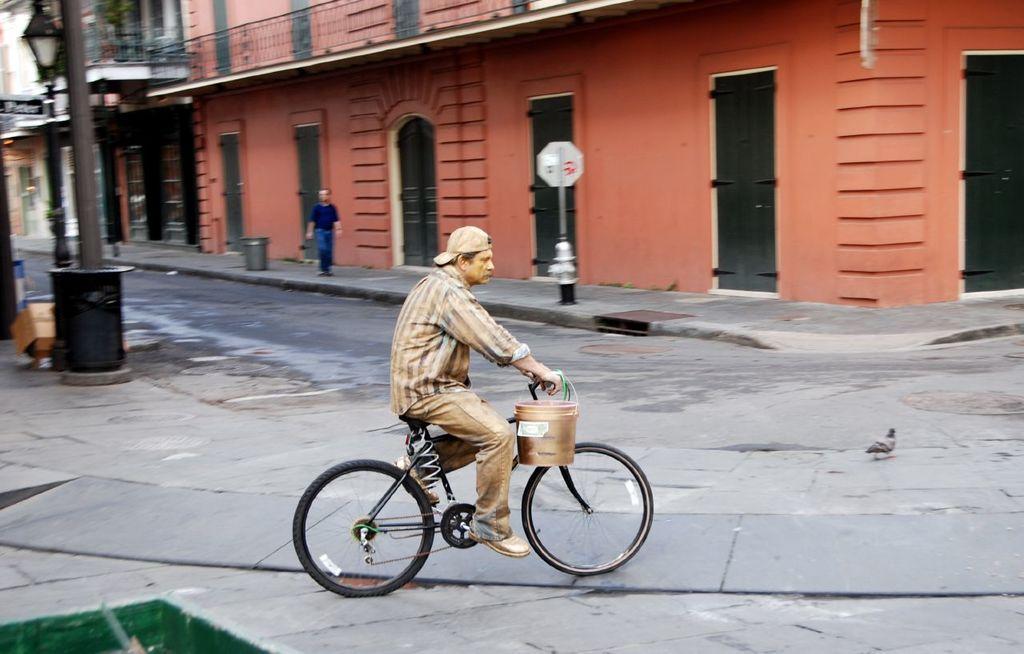In one or two sentences, can you explain what this image depicts? In this image we can see a man is riding on the bicycle with the bucket. In the background we can see a building and a pigeon on road. 